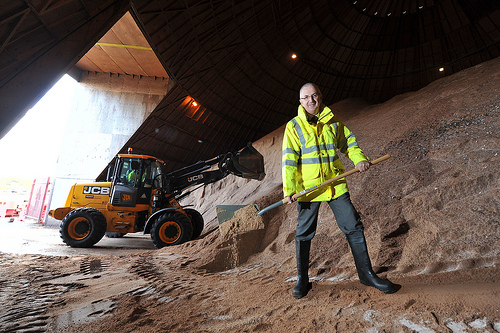<image>
Can you confirm if the man is behind the truck? No. The man is not behind the truck. From this viewpoint, the man appears to be positioned elsewhere in the scene. Is the man in front of the machine? Yes. The man is positioned in front of the machine, appearing closer to the camera viewpoint. Is the pant leg to the right of the bulldozer? Yes. From this viewpoint, the pant leg is positioned to the right side relative to the bulldozer. 